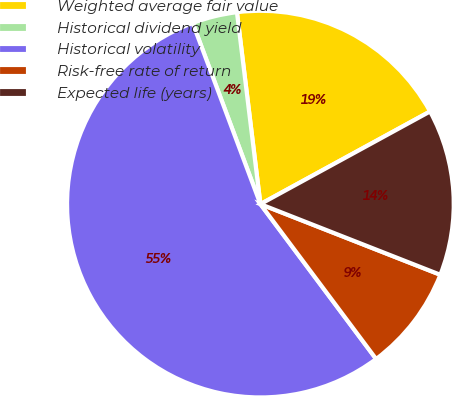Convert chart to OTSL. <chart><loc_0><loc_0><loc_500><loc_500><pie_chart><fcel>Weighted average fair value<fcel>Historical dividend yield<fcel>Historical volatility<fcel>Risk-free rate of return<fcel>Expected life (years)<nl><fcel>18.98%<fcel>3.76%<fcel>54.51%<fcel>8.83%<fcel>13.91%<nl></chart> 